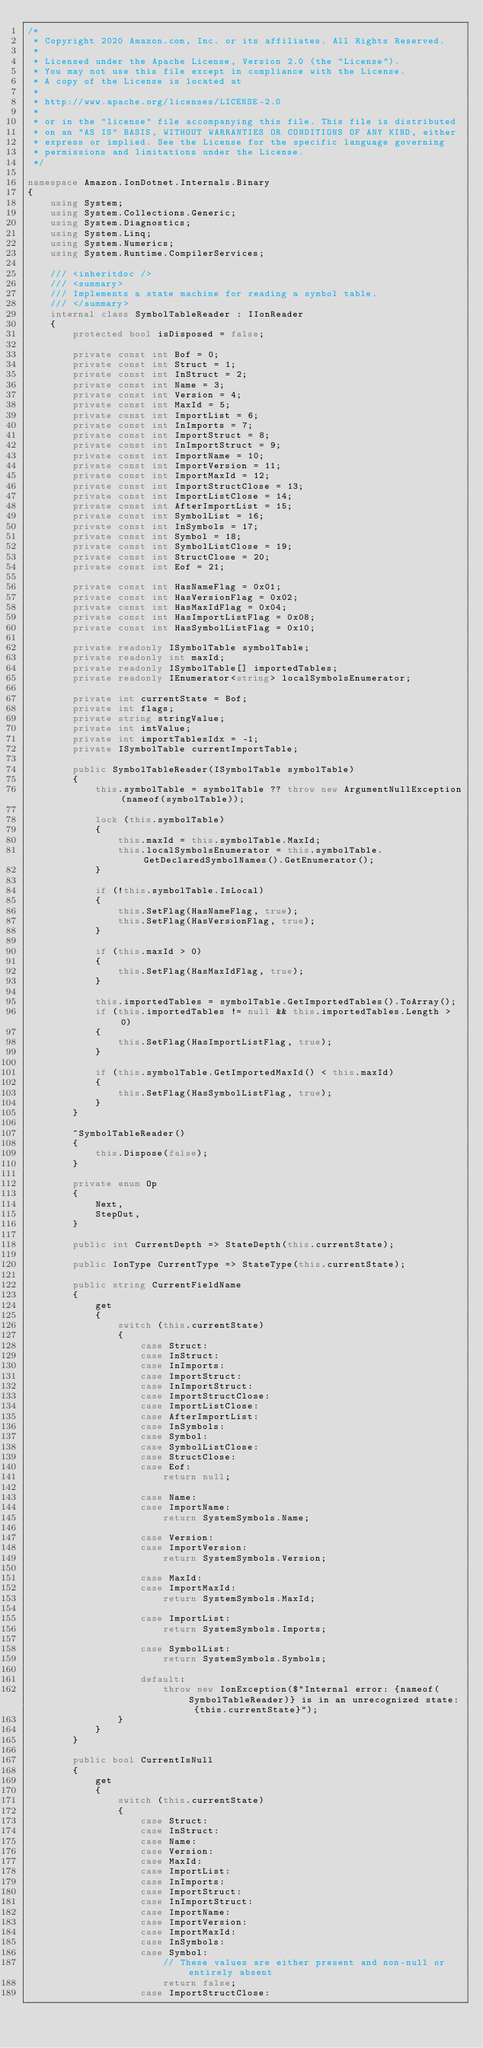<code> <loc_0><loc_0><loc_500><loc_500><_C#_>/*
 * Copyright 2020 Amazon.com, Inc. or its affiliates. All Rights Reserved.
 *
 * Licensed under the Apache License, Version 2.0 (the "License").
 * You may not use this file except in compliance with the License.
 * A copy of the License is located at
 *
 * http://www.apache.org/licenses/LICENSE-2.0
 *
 * or in the "license" file accompanying this file. This file is distributed
 * on an "AS IS" BASIS, WITHOUT WARRANTIES OR CONDITIONS OF ANY KIND, either
 * express or implied. See the License for the specific language governing
 * permissions and limitations under the License.
 */

namespace Amazon.IonDotnet.Internals.Binary
{
    using System;
    using System.Collections.Generic;
    using System.Diagnostics;
    using System.Linq;
    using System.Numerics;
    using System.Runtime.CompilerServices;

    /// <inheritdoc />
    /// <summary>
    /// Implements a state machine for reading a symbol table.
    /// </summary>
    internal class SymbolTableReader : IIonReader
    {
        protected bool isDisposed = false;

        private const int Bof = 0;
        private const int Struct = 1;
        private const int InStruct = 2;
        private const int Name = 3;
        private const int Version = 4;
        private const int MaxId = 5;
        private const int ImportList = 6;
        private const int InImports = 7;
        private const int ImportStruct = 8;
        private const int InImportStruct = 9;
        private const int ImportName = 10;
        private const int ImportVersion = 11;
        private const int ImportMaxId = 12;
        private const int ImportStructClose = 13;
        private const int ImportListClose = 14;
        private const int AfterImportList = 15;
        private const int SymbolList = 16;
        private const int InSymbols = 17;
        private const int Symbol = 18;
        private const int SymbolListClose = 19;
        private const int StructClose = 20;
        private const int Eof = 21;

        private const int HasNameFlag = 0x01;
        private const int HasVersionFlag = 0x02;
        private const int HasMaxIdFlag = 0x04;
        private const int HasImportListFlag = 0x08;
        private const int HasSymbolListFlag = 0x10;

        private readonly ISymbolTable symbolTable;
        private readonly int maxId;
        private readonly ISymbolTable[] importedTables;
        private readonly IEnumerator<string> localSymbolsEnumerator;

        private int currentState = Bof;
        private int flags;
        private string stringValue;
        private int intValue;
        private int importTablesIdx = -1;
        private ISymbolTable currentImportTable;

        public SymbolTableReader(ISymbolTable symbolTable)
        {
            this.symbolTable = symbolTable ?? throw new ArgumentNullException(nameof(symbolTable));

            lock (this.symbolTable)
            {
                this.maxId = this.symbolTable.MaxId;
                this.localSymbolsEnumerator = this.symbolTable.GetDeclaredSymbolNames().GetEnumerator();
            }

            if (!this.symbolTable.IsLocal)
            {
                this.SetFlag(HasNameFlag, true);
                this.SetFlag(HasVersionFlag, true);
            }

            if (this.maxId > 0)
            {
                this.SetFlag(HasMaxIdFlag, true);
            }

            this.importedTables = symbolTable.GetImportedTables().ToArray();
            if (this.importedTables != null && this.importedTables.Length > 0)
            {
                this.SetFlag(HasImportListFlag, true);
            }

            if (this.symbolTable.GetImportedMaxId() < this.maxId)
            {
                this.SetFlag(HasSymbolListFlag, true);
            }
        }

        ~SymbolTableReader()
        {
            this.Dispose(false);
        }

        private enum Op
        {
            Next,
            StepOut,
        }

        public int CurrentDepth => StateDepth(this.currentState);

        public IonType CurrentType => StateType(this.currentState);

        public string CurrentFieldName
        {
            get
            {
                switch (this.currentState)
                {
                    case Struct:
                    case InStruct:
                    case InImports:
                    case ImportStruct:
                    case InImportStruct:
                    case ImportStructClose:
                    case ImportListClose:
                    case AfterImportList:
                    case InSymbols:
                    case Symbol:
                    case SymbolListClose:
                    case StructClose:
                    case Eof:
                        return null;

                    case Name:
                    case ImportName:
                        return SystemSymbols.Name;

                    case Version:
                    case ImportVersion:
                        return SystemSymbols.Version;

                    case MaxId:
                    case ImportMaxId:
                        return SystemSymbols.MaxId;

                    case ImportList:
                        return SystemSymbols.Imports;

                    case SymbolList:
                        return SystemSymbols.Symbols;

                    default:
                        throw new IonException($"Internal error: {nameof(SymbolTableReader)} is in an unrecognized state: {this.currentState}");
                }
            }
        }

        public bool CurrentIsNull
        {
            get
            {
                switch (this.currentState)
                {
                    case Struct:
                    case InStruct:
                    case Name:
                    case Version:
                    case MaxId:
                    case ImportList:
                    case InImports:
                    case ImportStruct:
                    case InImportStruct:
                    case ImportName:
                    case ImportVersion:
                    case ImportMaxId:
                    case InSymbols:
                    case Symbol:
                        // These values are either present and non-null or entirely absent
                        return false;
                    case ImportStructClose:</code> 